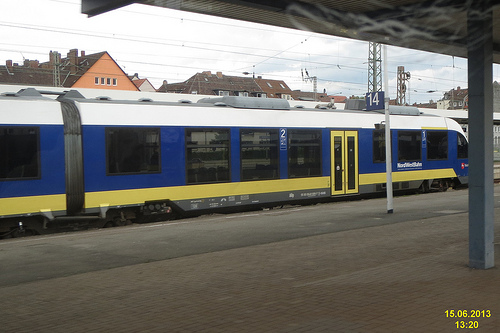What color is the house on the left side? The house on the left side, partially visible, seems to have an orange tint, but the color is not distinctly bright orange. 